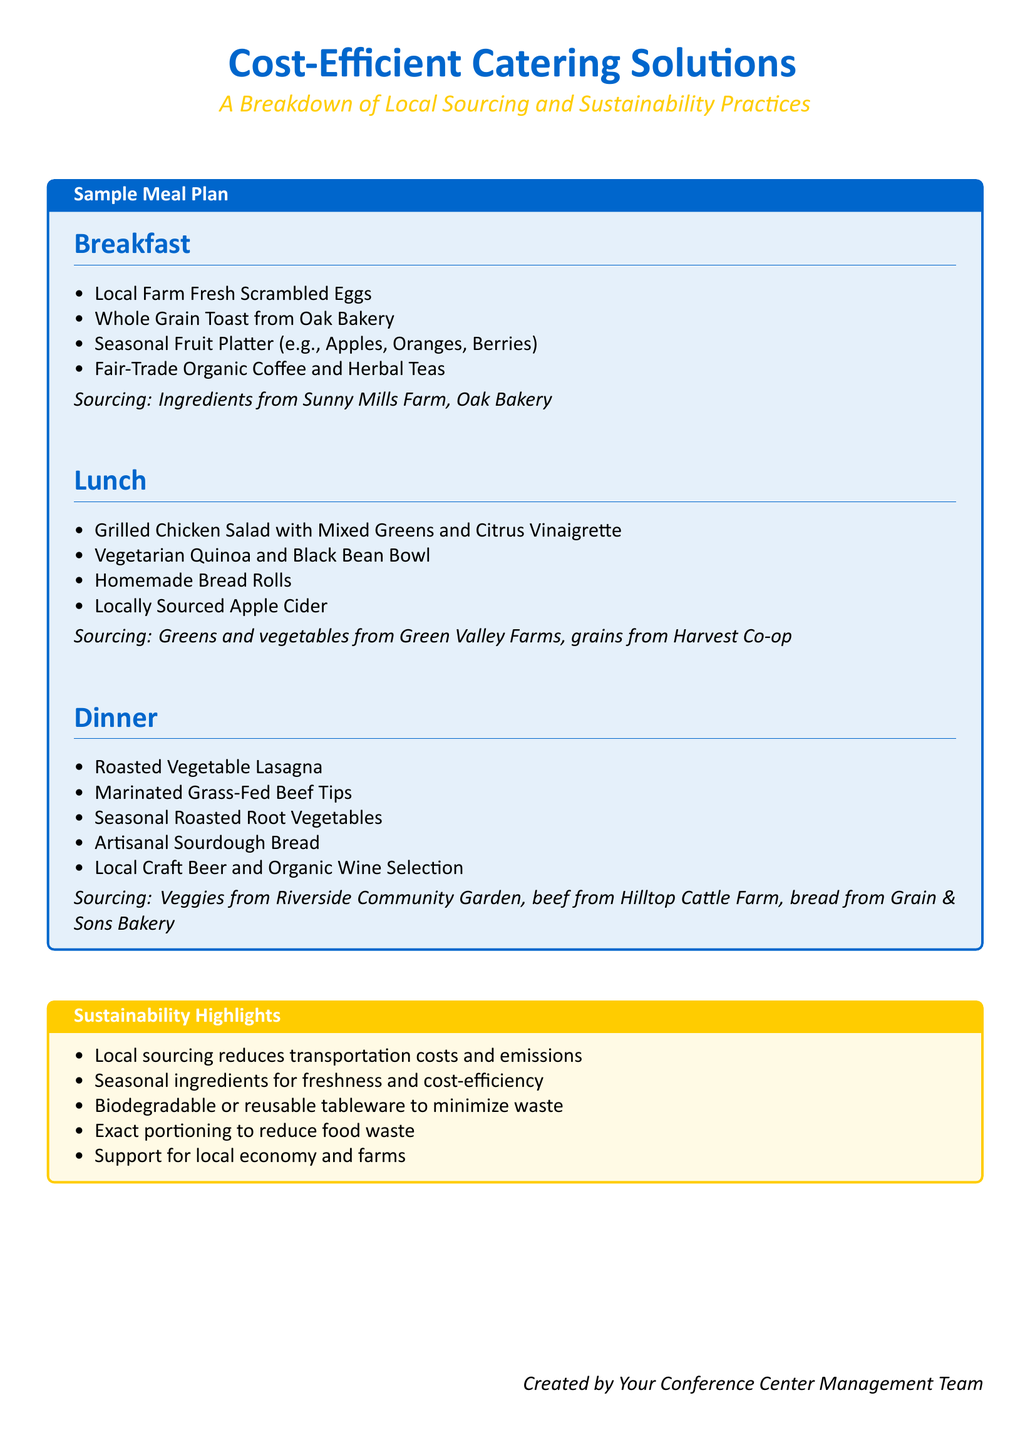What are the breakfast items? The breakfast items are listed under the Breakfast section of the document, including Scrambled Eggs and Toast.
Answer: Local Farm Fresh Scrambled Eggs, Whole Grain Toast, Seasonal Fruit Platter, Fair-Trade Organic Coffee and Herbal Teas Who provides the bread for lunch? The document specifies the supplier for homemade bread rolls in the Lunch section as Oak Bakery.
Answer: Oak Bakery What type of beverages are offered with dinner? The document lists the beverage options available with dinner, emphasizing them in the Dinner section.
Answer: Local Craft Beer and Organic Wine Selection What is a sustainability practice mentioned? The document outlines sustainability highlights, and this question relates to the practices mentioned.
Answer: Local sourcing reduces transportation costs and emissions What protein options are in the lunch meal plan? This question seeks to identify the protein selections in the Lunch section of the meal plan.
Answer: Grilled Chicken, Vegetarian Quinoa and Black Bean Bowl What sourcing location is mentioned for breakfast? This question looks for the sourcing location for breakfast ingredients as specified in the document.
Answer: Sunny Mills Farm, Oak Bakery How many sections are in the meal plan? The meal plan contains specific meal sections that can be counted for this answer.
Answer: Three What type of dietary option is emphasized in dinner? This question aims to highlight the specific dietary options provided in the Dinner section.
Answer: Marinated Grass-Fed Beef Tips 